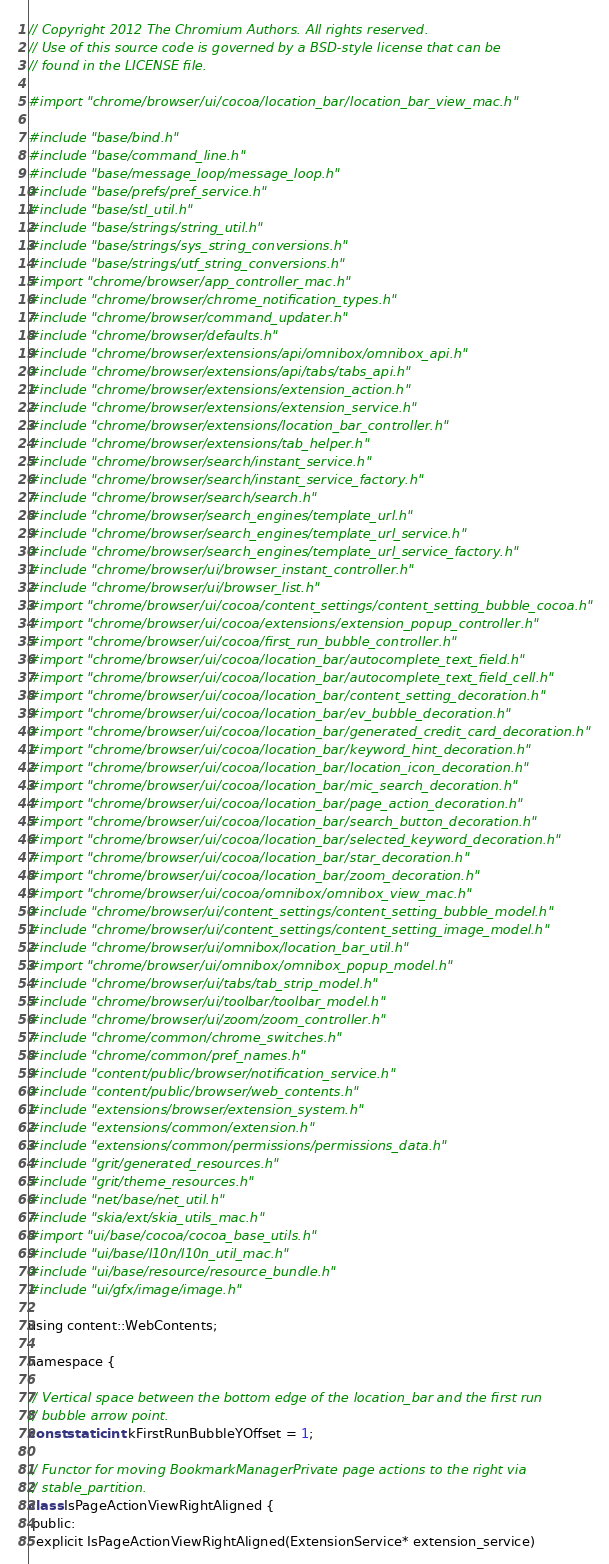<code> <loc_0><loc_0><loc_500><loc_500><_ObjectiveC_>// Copyright 2012 The Chromium Authors. All rights reserved.
// Use of this source code is governed by a BSD-style license that can be
// found in the LICENSE file.

#import "chrome/browser/ui/cocoa/location_bar/location_bar_view_mac.h"

#include "base/bind.h"
#include "base/command_line.h"
#include "base/message_loop/message_loop.h"
#include "base/prefs/pref_service.h"
#include "base/stl_util.h"
#include "base/strings/string_util.h"
#include "base/strings/sys_string_conversions.h"
#include "base/strings/utf_string_conversions.h"
#import "chrome/browser/app_controller_mac.h"
#include "chrome/browser/chrome_notification_types.h"
#include "chrome/browser/command_updater.h"
#include "chrome/browser/defaults.h"
#include "chrome/browser/extensions/api/omnibox/omnibox_api.h"
#include "chrome/browser/extensions/api/tabs/tabs_api.h"
#include "chrome/browser/extensions/extension_action.h"
#include "chrome/browser/extensions/extension_service.h"
#include "chrome/browser/extensions/location_bar_controller.h"
#include "chrome/browser/extensions/tab_helper.h"
#include "chrome/browser/search/instant_service.h"
#include "chrome/browser/search/instant_service_factory.h"
#include "chrome/browser/search/search.h"
#include "chrome/browser/search_engines/template_url.h"
#include "chrome/browser/search_engines/template_url_service.h"
#include "chrome/browser/search_engines/template_url_service_factory.h"
#include "chrome/browser/ui/browser_instant_controller.h"
#include "chrome/browser/ui/browser_list.h"
#import "chrome/browser/ui/cocoa/content_settings/content_setting_bubble_cocoa.h"
#import "chrome/browser/ui/cocoa/extensions/extension_popup_controller.h"
#import "chrome/browser/ui/cocoa/first_run_bubble_controller.h"
#import "chrome/browser/ui/cocoa/location_bar/autocomplete_text_field.h"
#import "chrome/browser/ui/cocoa/location_bar/autocomplete_text_field_cell.h"
#import "chrome/browser/ui/cocoa/location_bar/content_setting_decoration.h"
#import "chrome/browser/ui/cocoa/location_bar/ev_bubble_decoration.h"
#import "chrome/browser/ui/cocoa/location_bar/generated_credit_card_decoration.h"
#import "chrome/browser/ui/cocoa/location_bar/keyword_hint_decoration.h"
#import "chrome/browser/ui/cocoa/location_bar/location_icon_decoration.h"
#import "chrome/browser/ui/cocoa/location_bar/mic_search_decoration.h"
#import "chrome/browser/ui/cocoa/location_bar/page_action_decoration.h"
#import "chrome/browser/ui/cocoa/location_bar/search_button_decoration.h"
#import "chrome/browser/ui/cocoa/location_bar/selected_keyword_decoration.h"
#import "chrome/browser/ui/cocoa/location_bar/star_decoration.h"
#import "chrome/browser/ui/cocoa/location_bar/zoom_decoration.h"
#import "chrome/browser/ui/cocoa/omnibox/omnibox_view_mac.h"
#include "chrome/browser/ui/content_settings/content_setting_bubble_model.h"
#include "chrome/browser/ui/content_settings/content_setting_image_model.h"
#include "chrome/browser/ui/omnibox/location_bar_util.h"
#import "chrome/browser/ui/omnibox/omnibox_popup_model.h"
#include "chrome/browser/ui/tabs/tab_strip_model.h"
#include "chrome/browser/ui/toolbar/toolbar_model.h"
#include "chrome/browser/ui/zoom/zoom_controller.h"
#include "chrome/common/chrome_switches.h"
#include "chrome/common/pref_names.h"
#include "content/public/browser/notification_service.h"
#include "content/public/browser/web_contents.h"
#include "extensions/browser/extension_system.h"
#include "extensions/common/extension.h"
#include "extensions/common/permissions/permissions_data.h"
#include "grit/generated_resources.h"
#include "grit/theme_resources.h"
#include "net/base/net_util.h"
#include "skia/ext/skia_utils_mac.h"
#import "ui/base/cocoa/cocoa_base_utils.h"
#include "ui/base/l10n/l10n_util_mac.h"
#include "ui/base/resource/resource_bundle.h"
#include "ui/gfx/image/image.h"

using content::WebContents;

namespace {

// Vertical space between the bottom edge of the location_bar and the first run
// bubble arrow point.
const static int kFirstRunBubbleYOffset = 1;

// Functor for moving BookmarkManagerPrivate page actions to the right via
// stable_partition.
class IsPageActionViewRightAligned {
 public:
  explicit IsPageActionViewRightAligned(ExtensionService* extension_service)</code> 